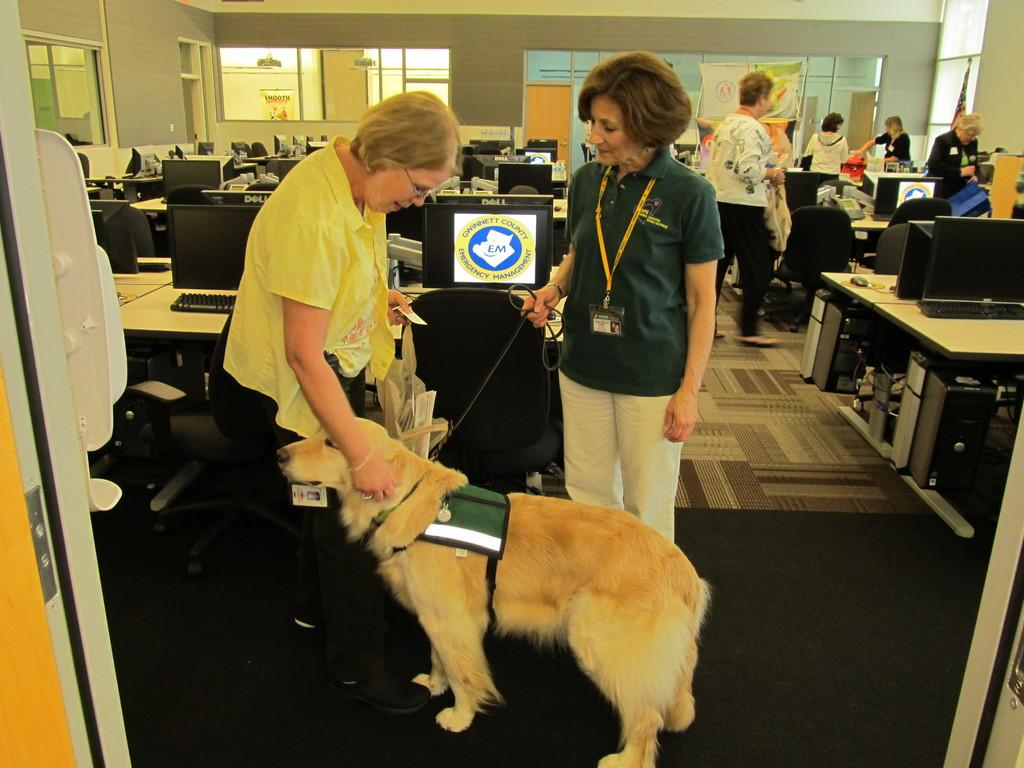Who or what can be seen in the image? There are people and a dog in the image. What objects are present in the image? There are computers on tables in the image. What type of toothbrush is the dog using in the image? There is no toothbrush present in the image, and the dog is not using one. 